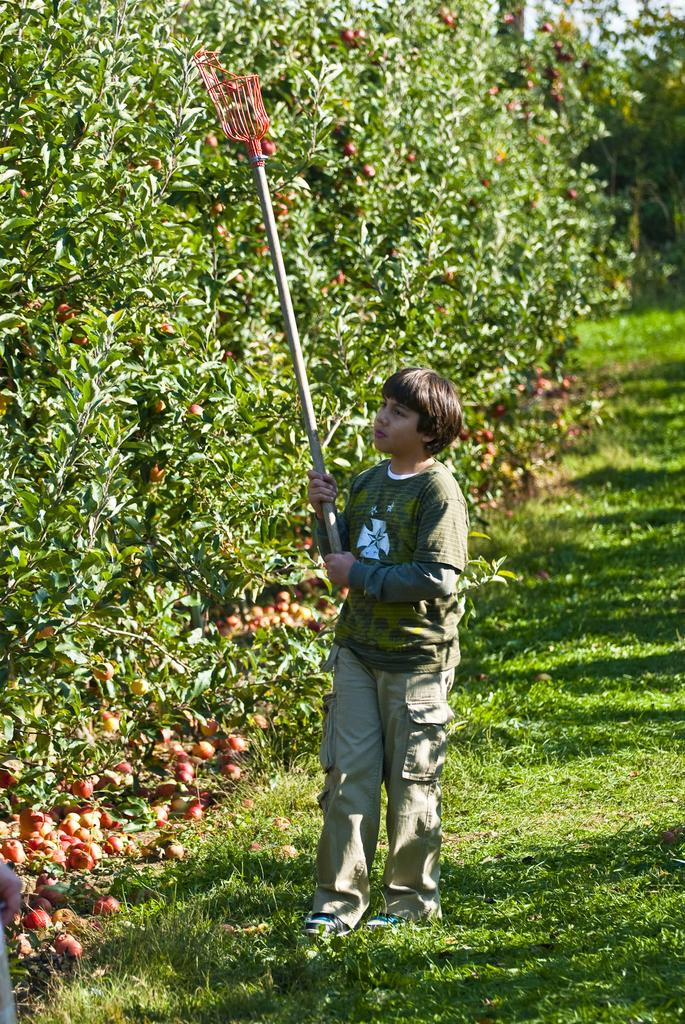Who is the main subject in the picture? There is a boy in the picture. What is the boy doing in the image? The boy is standing and holding a fruit picker. What can be seen in the background of the picture? There are fruits and trees in the background of the picture. What type of quilt is being used to pick the fruits in the image? There is no quilt present in the image; the boy is using a fruit picker to reach the fruits. Can you see any salt on the fruits in the image? There is no salt visible on the fruits in the image. 